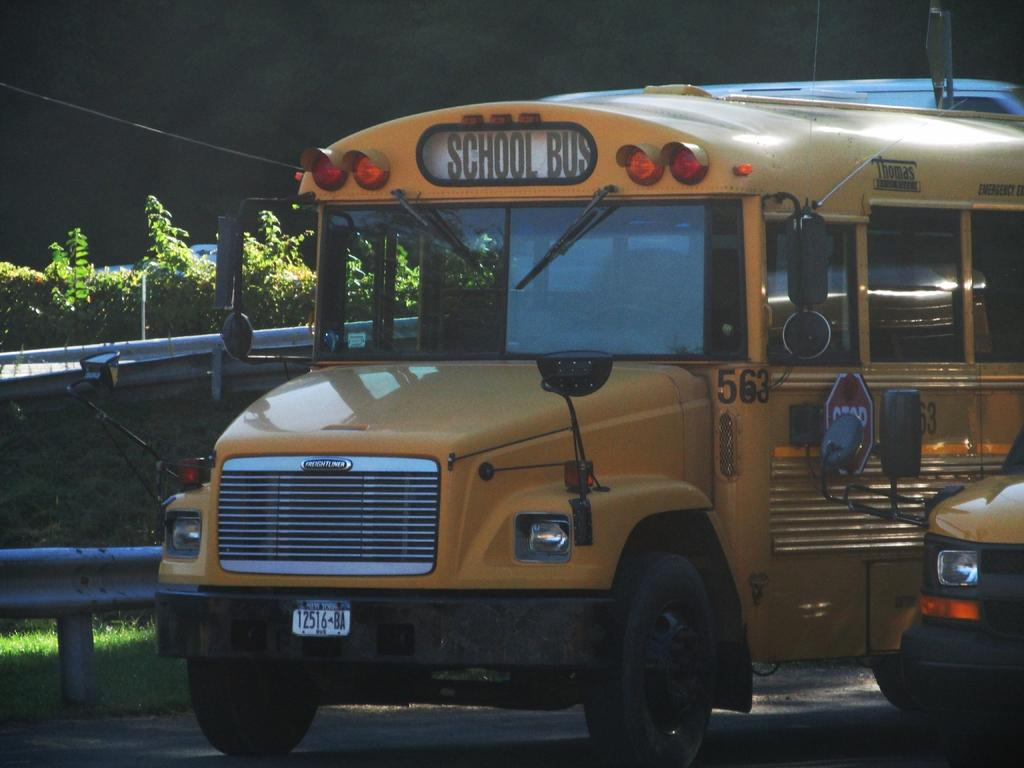What type of vehicle is in the image? There is a school bus in the image. Can you describe the setting of the image? There is a vehicle on the road in the image, and there is grass and plants in the background. How many dogs can be seen interacting with the school bus in the image? There are no dogs present in the image. What type of men are visible in the image? There are no men present in the image. 